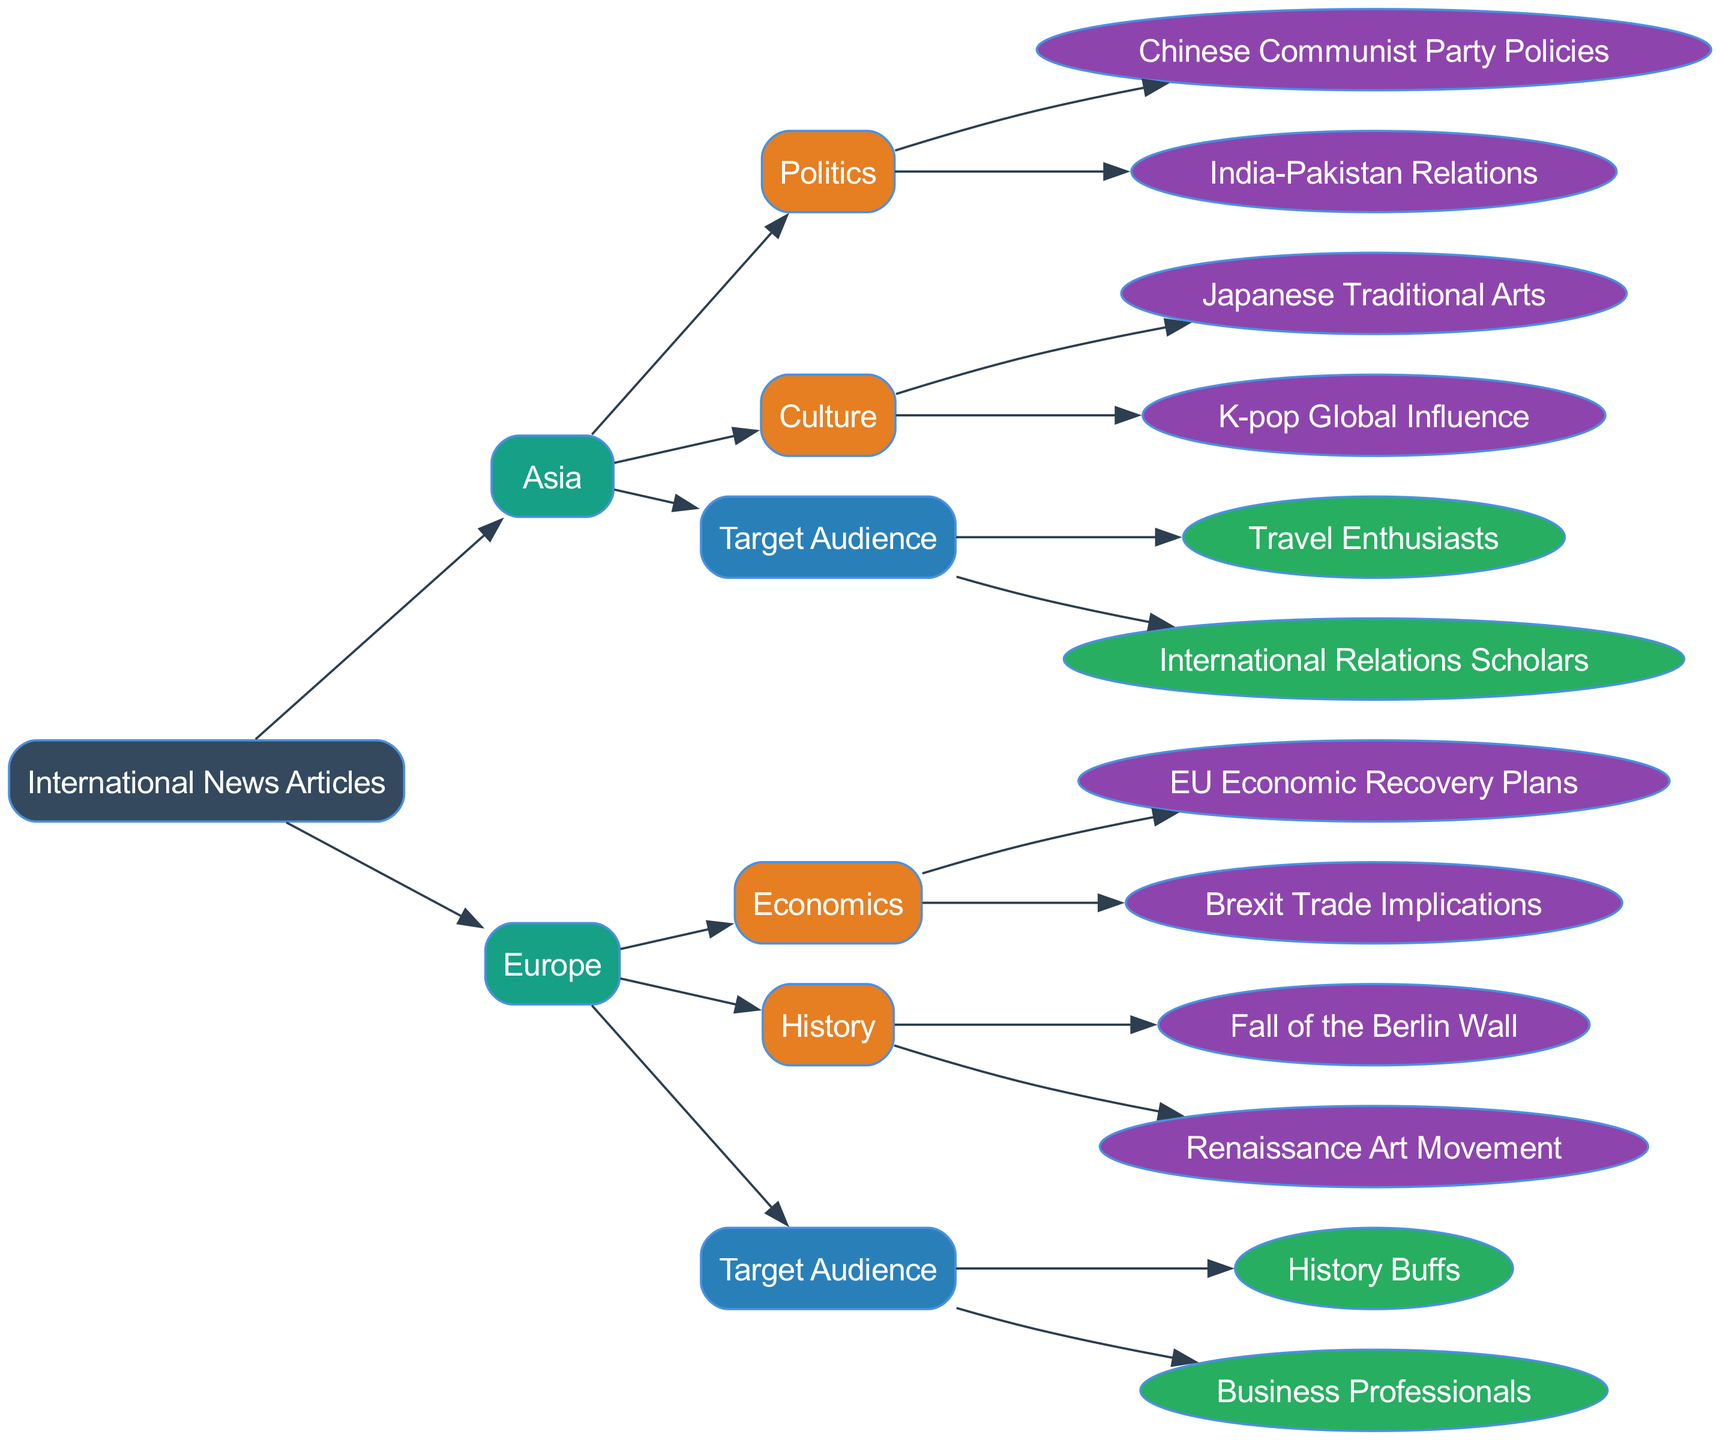What are the topics under Asian Politics? The diagram shows the region "Asia," and within its "Politics" category, the topics listed are "Chinese Communist Party Policies" and "India-Pakistan Relations."
Answer: Chinese Communist Party Policies, India-Pakistan Relations How many target audiences are there for European articles? Looking at the "Europe" region, there are two target audiences mentioned: "History Buffs" and "Business Professionals," which makes a total of two.
Answer: 2 What is the subtopic under Culture in Asia? In the "Culture" category for the "Asia" region, there are two subtopics listed: "Japanese Traditional Arts" and "K-pop Global Influence."
Answer: Japanese Traditional Arts, K-pop Global Influence Which audience is targeted in the Asian news articles? The diagram specifies two target audiences under the "Asia" region: "Travel Enthusiasts" and "International Relations Scholars."
Answer: Travel Enthusiasts, International Relations Scholars What is the relationship between Europe and its Economics topic? Europe has a "Topics" category which includes "Economics," and under that, there are two specific topics: "EU Economic Recovery Plans" and "Brexit Trade Implications," showing the link between the region and its economic discussions.
Answer: Economics How many topics are listed under European History? Within the "History" category for the "Europe" region, there are two topics mentioned: "Fall of the Berlin Wall" and "Renaissance Art Movement," resulting in a total of two.
Answer: 2 What are the two main regions depicted in the diagram? The diagram illustrates two regions categorized under International News Articles: "Asia" and "Europe."
Answer: Asia, Europe Which subtopic relates to Japanese culture? Looking at the "Culture" under the "Asia" region, "Japanese Traditional Arts" is the subtopic specifically related to Japanese culture.
Answer: Japanese Traditional Arts How many edges connect the "root" node to regions? The "root" node connects to two regions: "Asia" and "Europe." Therefore, there are two edges originating from the root node.
Answer: 2 